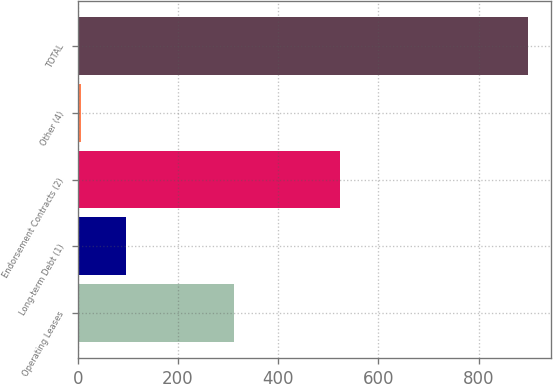Convert chart to OTSL. <chart><loc_0><loc_0><loc_500><loc_500><bar_chart><fcel>Operating Leases<fcel>Long-term Debt (1)<fcel>Endorsement Contracts (2)<fcel>Other (4)<fcel>TOTAL<nl><fcel>311<fcel>96.2<fcel>524<fcel>7<fcel>899<nl></chart> 